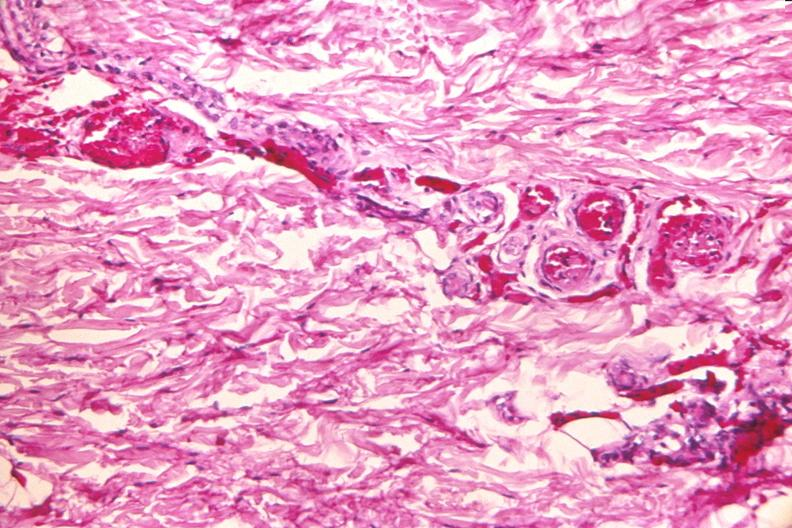does this image show skin, petechial hemorrhages from patient with meningococcemia?
Answer the question using a single word or phrase. Yes 